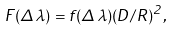<formula> <loc_0><loc_0><loc_500><loc_500>F ( \Delta \lambda ) = f ( \Delta \lambda ) ( D / R ) { ^ { 2 } } ,</formula> 